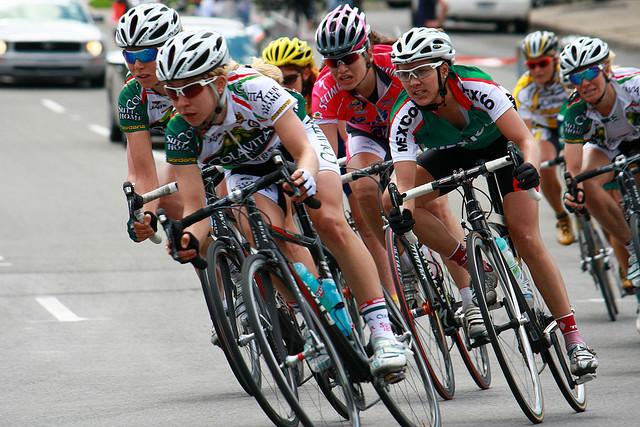Are the bicycles moving fast?
Answer briefly. Yes. What is the player doing?
Give a very brief answer. Riding bike. What player is wearing a yellow helmet?
Keep it brief. 1 in back. What are they wearing on their heads?
Give a very brief answer. Helmets. 